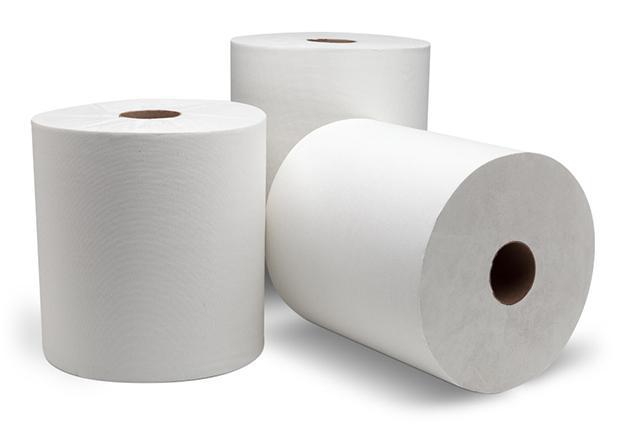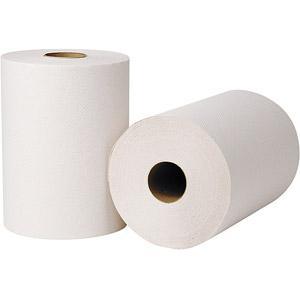The first image is the image on the left, the second image is the image on the right. For the images displayed, is the sentence "There are three rolls of paper towels." factually correct? Answer yes or no. No. 